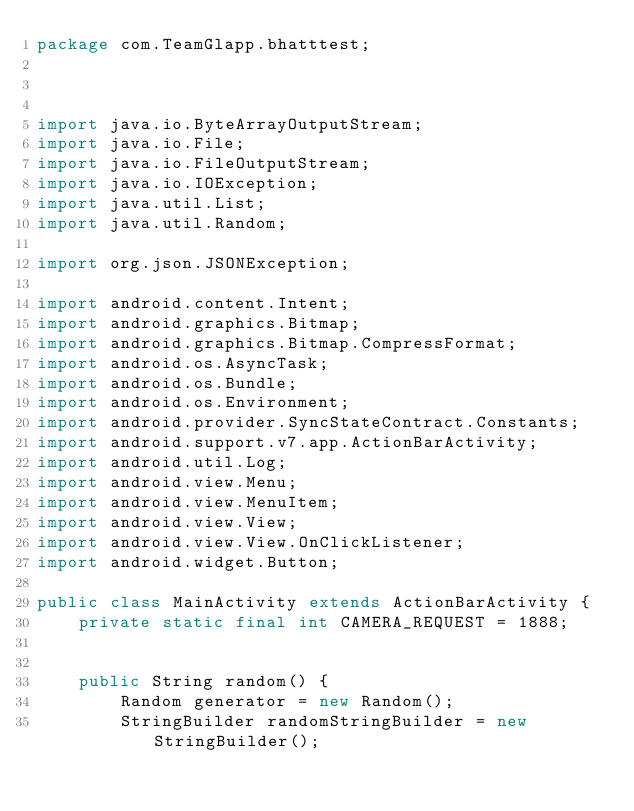Convert code to text. <code><loc_0><loc_0><loc_500><loc_500><_Java_>package com.TeamGlapp.bhatttest;



import java.io.ByteArrayOutputStream;
import java.io.File;
import java.io.FileOutputStream;
import java.io.IOException;
import java.util.List;
import java.util.Random;

import org.json.JSONException;

import android.content.Intent;
import android.graphics.Bitmap;
import android.graphics.Bitmap.CompressFormat;
import android.os.AsyncTask;
import android.os.Bundle;
import android.os.Environment;
import android.provider.SyncStateContract.Constants;
import android.support.v7.app.ActionBarActivity;
import android.util.Log;
import android.view.Menu;
import android.view.MenuItem;
import android.view.View;
import android.view.View.OnClickListener;
import android.widget.Button;

public class MainActivity extends ActionBarActivity {
	private static final int CAMERA_REQUEST = 1888;
	
	
	public String random() {
		Random generator = new Random();
		StringBuilder randomStringBuilder = new StringBuilder();</code> 